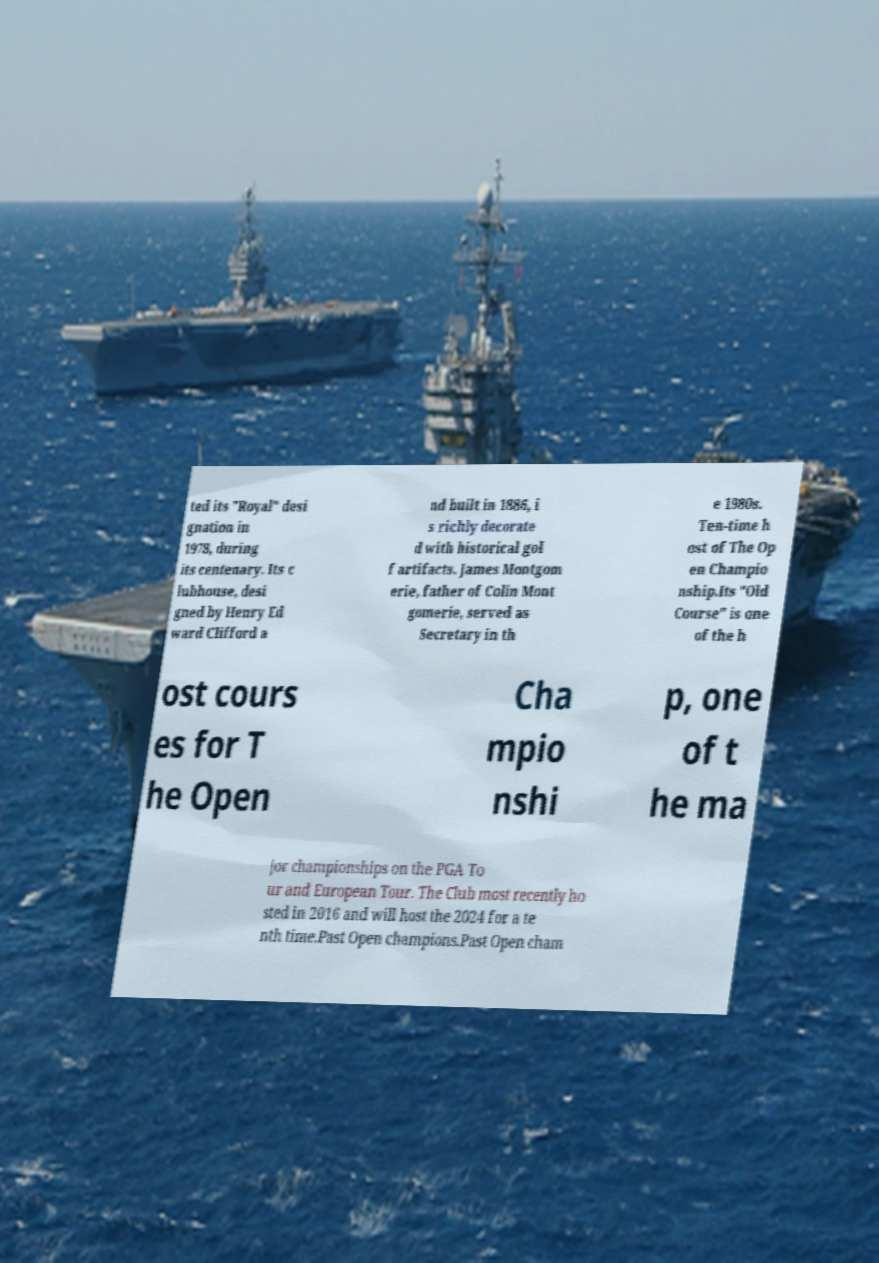Could you extract and type out the text from this image? ted its "Royal" desi gnation in 1978, during its centenary. Its c lubhouse, desi gned by Henry Ed ward Clifford a nd built in 1886, i s richly decorate d with historical gol f artifacts. James Montgom erie, father of Colin Mont gomerie, served as Secretary in th e 1980s. Ten-time h ost of The Op en Champio nship.Its "Old Course" is one of the h ost cours es for T he Open Cha mpio nshi p, one of t he ma jor championships on the PGA To ur and European Tour. The Club most recently ho sted in 2016 and will host the 2024 for a te nth time.Past Open champions.Past Open cham 